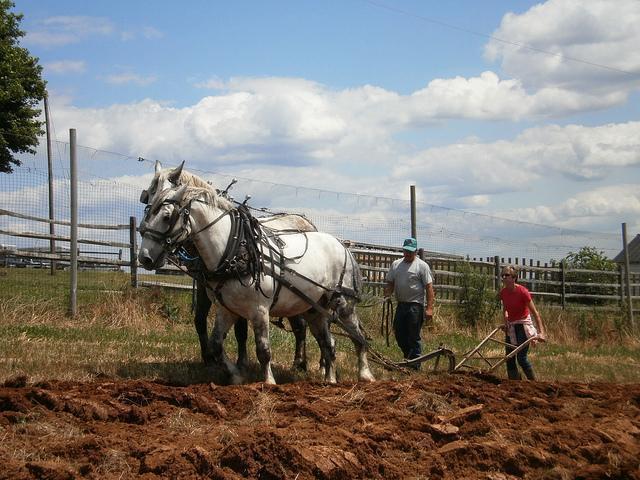How many people are there?
Give a very brief answer. 2. How many horses are there?
Give a very brief answer. 2. 